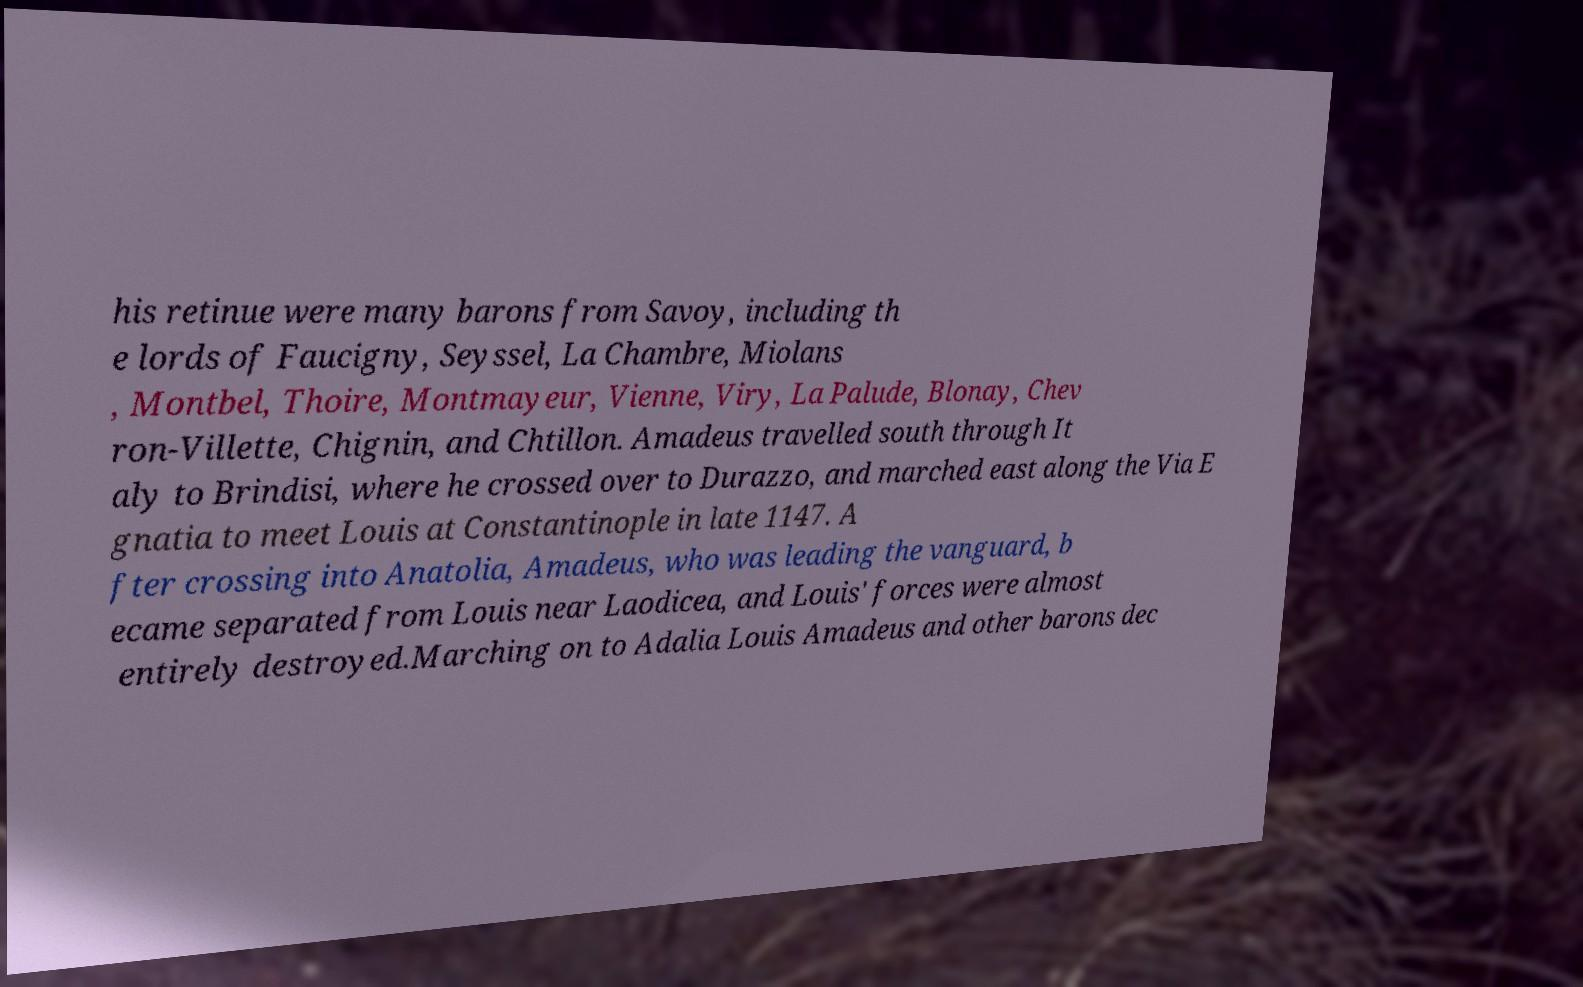Please identify and transcribe the text found in this image. his retinue were many barons from Savoy, including th e lords of Faucigny, Seyssel, La Chambre, Miolans , Montbel, Thoire, Montmayeur, Vienne, Viry, La Palude, Blonay, Chev ron-Villette, Chignin, and Chtillon. Amadeus travelled south through It aly to Brindisi, where he crossed over to Durazzo, and marched east along the Via E gnatia to meet Louis at Constantinople in late 1147. A fter crossing into Anatolia, Amadeus, who was leading the vanguard, b ecame separated from Louis near Laodicea, and Louis' forces were almost entirely destroyed.Marching on to Adalia Louis Amadeus and other barons dec 